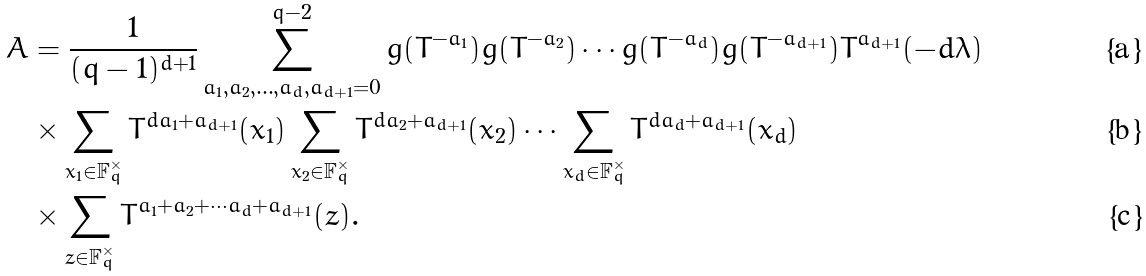<formula> <loc_0><loc_0><loc_500><loc_500>A & = \frac { 1 } { ( q - 1 ) ^ { d + 1 } } \sum _ { a _ { 1 } , a _ { 2 } , \dots , a _ { d } , a _ { d + 1 } = 0 } ^ { q - 2 } g ( T ^ { - a _ { 1 } } ) g ( T ^ { - a _ { 2 } } ) \cdots g ( T ^ { - a _ { d } } ) g ( T ^ { - a _ { d + 1 } } ) T ^ { a _ { d + 1 } } ( - d \lambda ) \\ & \times \sum _ { x _ { 1 } \in \mathbb { F } _ { q } ^ { \times } } T ^ { d a _ { 1 } + a _ { d + 1 } } ( x _ { 1 } ) \sum _ { x _ { 2 } \in \mathbb { F } _ { q } ^ { \times } } T ^ { d a _ { 2 } + a _ { d + 1 } } ( x _ { 2 } ) \cdots \sum _ { x _ { d } \in \mathbb { F } _ { q } ^ { \times } } T ^ { d a _ { d } + a _ { d + 1 } } ( x _ { d } ) \\ & \times \sum _ { z \in \mathbb { F } _ { q } ^ { \times } } T ^ { a _ { 1 } + a _ { 2 } + \cdots a _ { d } + a _ { d + 1 } } ( z ) .</formula> 